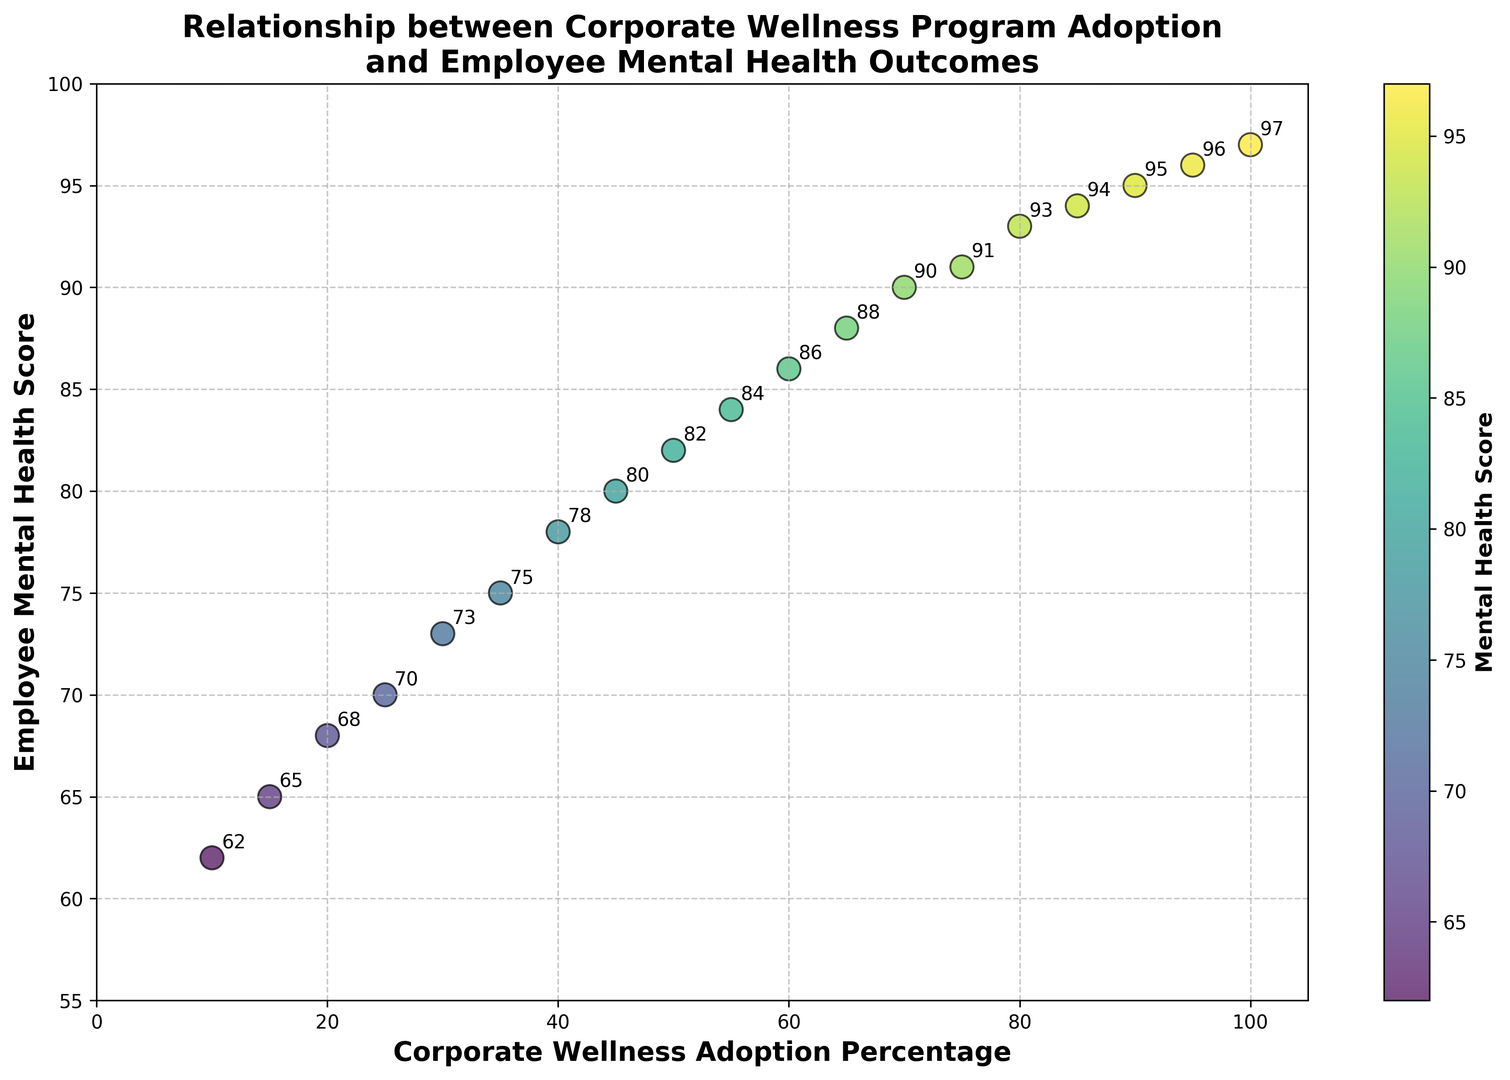What is the general trend observed between corporate wellness program adoption and employee mental health scores? As the corporate wellness adoption percentage increases, the employee mental health score generally increases as well. This is indicated by the upward trend observed in the scatter plot.
Answer: Positive correlation What is the employee mental health score when the corporate wellness adoption percentage is 50%? Look at the data point where the x-axis value is 50. The corresponding y-axis value, which represents the employee mental health score, is 82.
Answer: 82 Which data point has the highest employee mental health score and what is the corresponding corporate wellness adoption percentage? Look at the highest point on the y-axis. The highest employee mental health score is 97, corresponding to a 100% corporate wellness adoption percentage.
Answer: 97, 100% By how much does the employee mental health score increase on average for every 10% increase in corporate wellness adoption? To find the average increase, first identify the range of scores and the range of wellness adoption percentages. The scores range from 62 to 97 (a difference of 35), and the adoption percentage ranges from 10% to 100% (a difference of 90%). Divide the total increase in scores by the total increase in adoption percentages and then multiply by 10. (35/90) * 10 ≈ 3.89.
Answer: Approximately 3.89 Is there any corporate wellness adoption percentage where the change in employee mental health score becomes less significant? From the scatter plot, it appears that beyond 85% corporate wellness adoption, the increase in employee mental health score starts to plateau, indicating diminishing returns.
Answer: Beyond 85% Which range of corporate wellness adoption percentages shows the most significant improvement in employee mental health scores? Observe the slope of the trend line within different ranges. The most significant improvement appears between the 10%-60% range.
Answer: 10%-60% What is the correlation coefficient between corporate wellness adoption percentage and employee mental health score? A correlation coefficient quantifies the degree to which two variables are related. Based on visual observation, there is a strong positive correlation, likely greater than 0.9. To get the exact number, one would need to calculate it using statistical software, but based on the plot, it looks very strong.
Answer: Strong positive correlation (likely > 0.9 based on visual estimation) How does the color gradient relate to employee mental health scores, and what is the significance of this visual feature? The color gradient (ranging from dark purple to light yellow-green) represents the different levels of employee mental health scores. Darker colors correspond to lower scores and lighter colors to higher scores. This visual feature helps quickly identify regions with higher or lower scores.
Answer: Darker colors = lower scores, Lighter colors = higher scores 